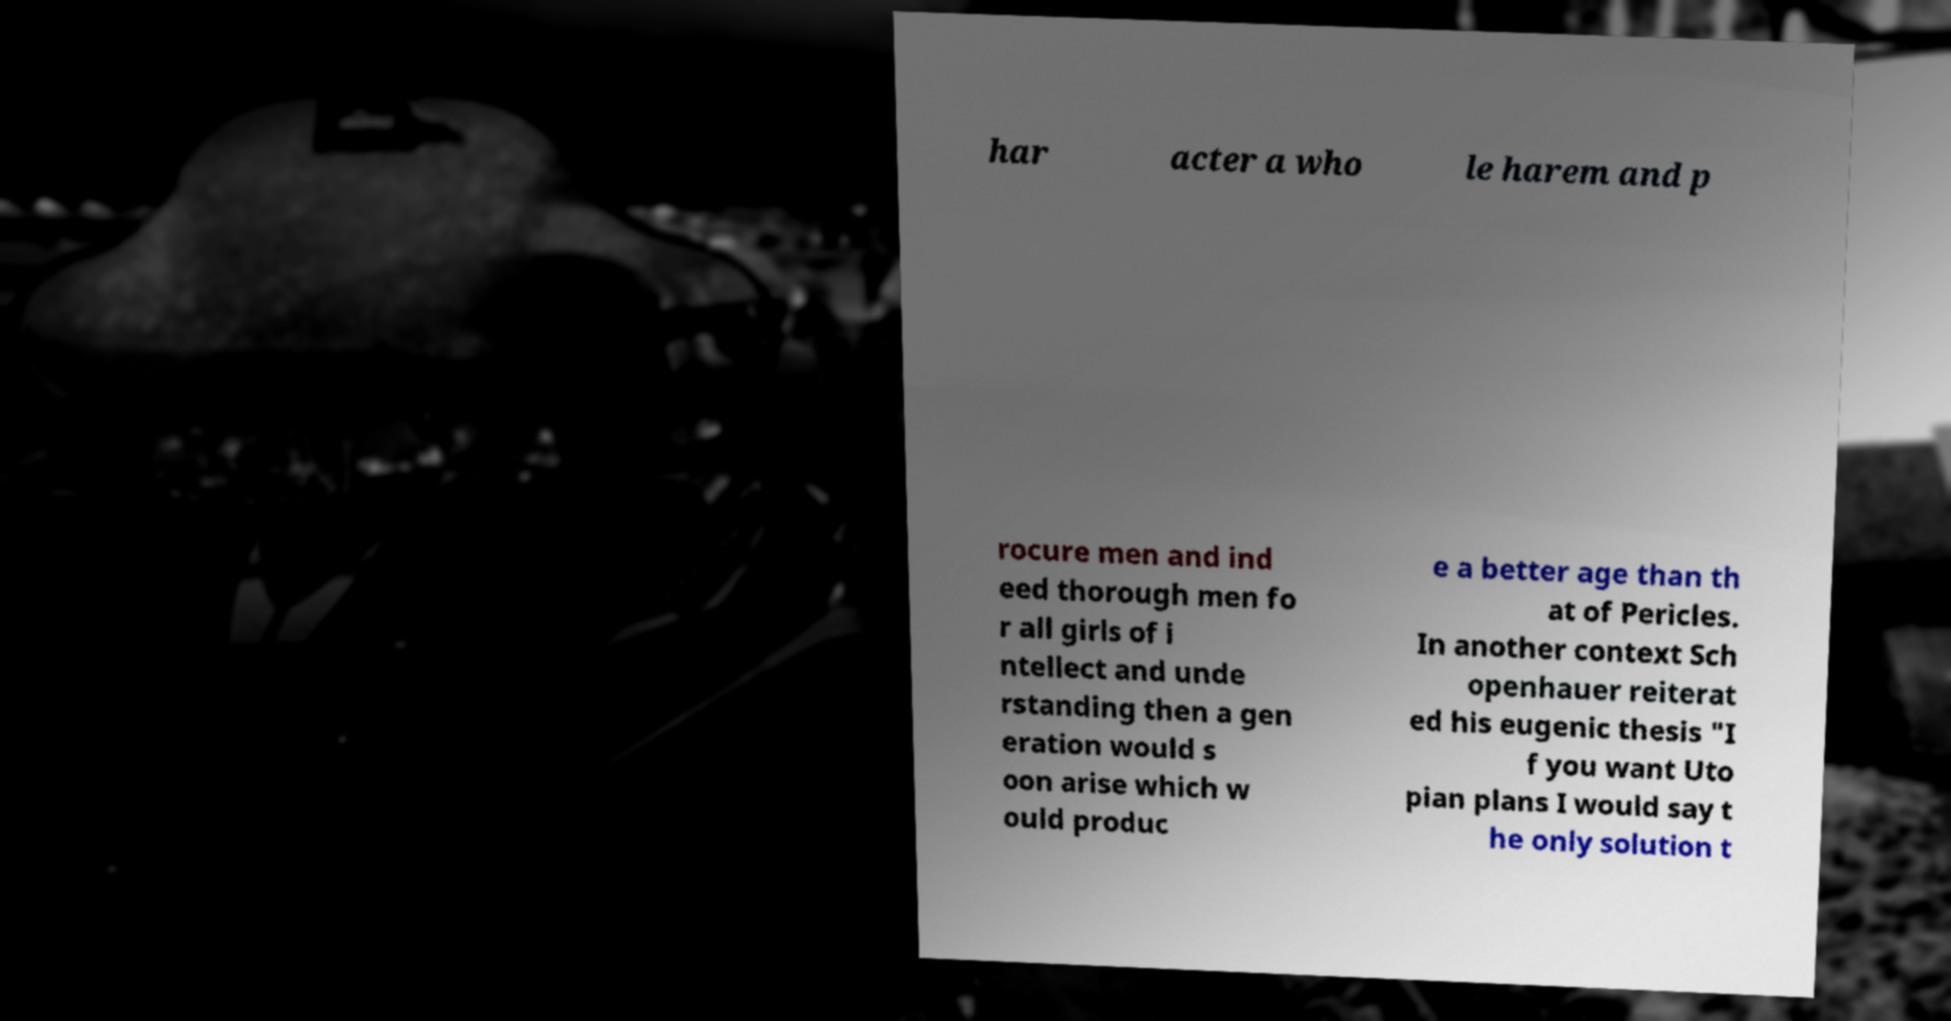Could you extract and type out the text from this image? har acter a who le harem and p rocure men and ind eed thorough men fo r all girls of i ntellect and unde rstanding then a gen eration would s oon arise which w ould produc e a better age than th at of Pericles. In another context Sch openhauer reiterat ed his eugenic thesis "I f you want Uto pian plans I would say t he only solution t 